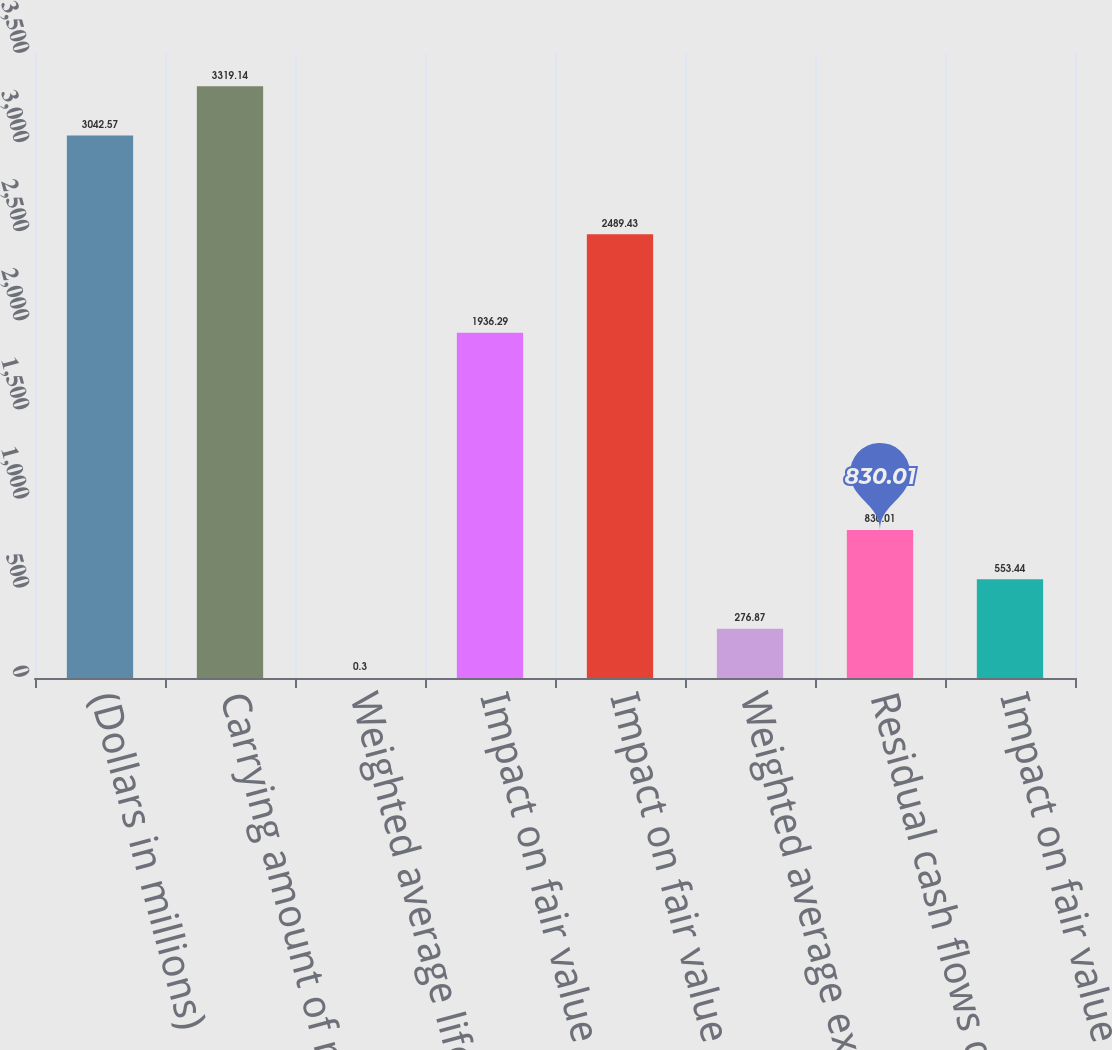<chart> <loc_0><loc_0><loc_500><loc_500><bar_chart><fcel>(Dollars in millions)<fcel>Carrying amount of residual<fcel>Weighted average life to call<fcel>Impact on fair value of 10<fcel>Impact on fair value of 25<fcel>Weighted average expected<fcel>Residual cash flows discount<fcel>Impact on fair value of 100<nl><fcel>3042.57<fcel>3319.14<fcel>0.3<fcel>1936.29<fcel>2489.43<fcel>276.87<fcel>830.01<fcel>553.44<nl></chart> 